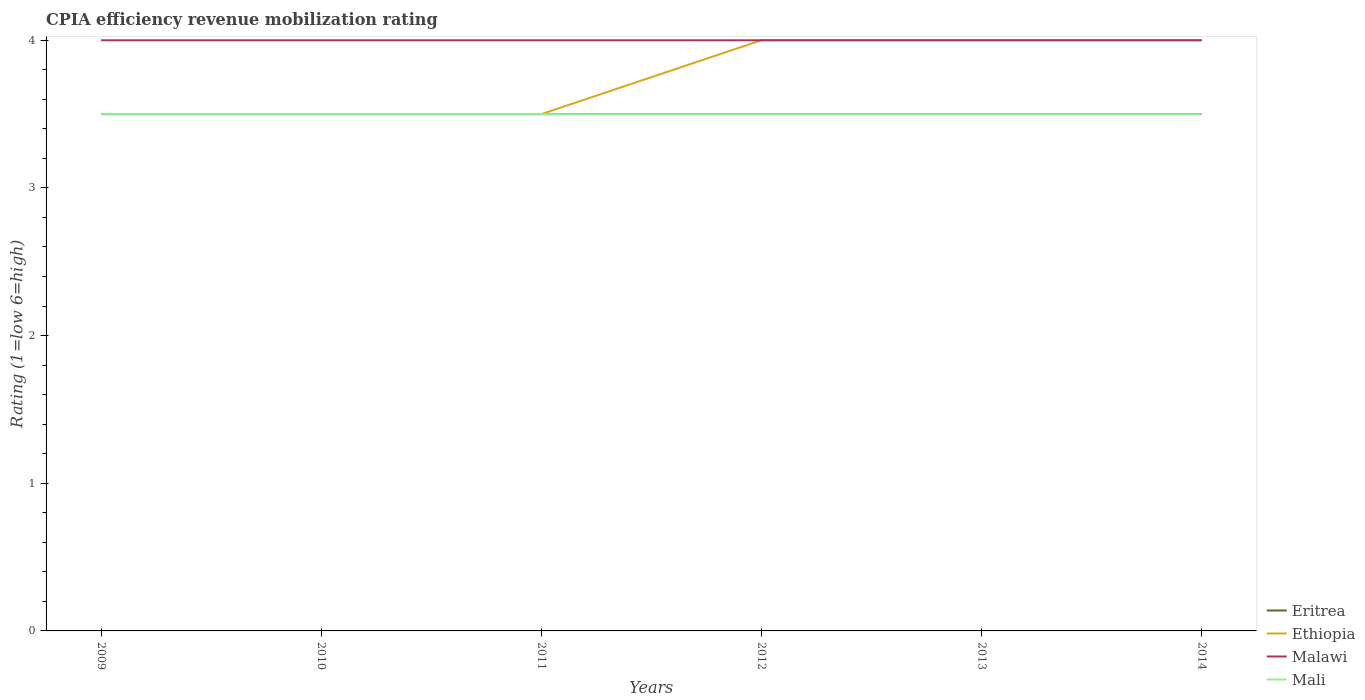How many different coloured lines are there?
Give a very brief answer. 4. Across all years, what is the maximum CPIA rating in Malawi?
Keep it short and to the point. 4. What is the total CPIA rating in Mali in the graph?
Provide a succinct answer. 0. What is the difference between two consecutive major ticks on the Y-axis?
Your response must be concise. 1. Does the graph contain grids?
Your answer should be very brief. No. Where does the legend appear in the graph?
Keep it short and to the point. Bottom right. How many legend labels are there?
Keep it short and to the point. 4. How are the legend labels stacked?
Your response must be concise. Vertical. What is the title of the graph?
Give a very brief answer. CPIA efficiency revenue mobilization rating. What is the label or title of the Y-axis?
Your answer should be compact. Rating (1=low 6=high). What is the Rating (1=low 6=high) of Ethiopia in 2009?
Your answer should be compact. 3.5. What is the Rating (1=low 6=high) in Malawi in 2009?
Ensure brevity in your answer.  4. What is the Rating (1=low 6=high) in Eritrea in 2010?
Your answer should be very brief. 3.5. What is the Rating (1=low 6=high) in Ethiopia in 2011?
Offer a terse response. 3.5. What is the Rating (1=low 6=high) in Mali in 2011?
Give a very brief answer. 3.5. What is the Rating (1=low 6=high) in Eritrea in 2012?
Make the answer very short. 3.5. What is the Rating (1=low 6=high) of Malawi in 2012?
Your response must be concise. 4. What is the Rating (1=low 6=high) of Mali in 2012?
Offer a terse response. 3.5. What is the Rating (1=low 6=high) of Eritrea in 2013?
Provide a short and direct response. 3.5. What is the Rating (1=low 6=high) in Mali in 2013?
Provide a short and direct response. 3.5. What is the Rating (1=low 6=high) of Ethiopia in 2014?
Give a very brief answer. 4. What is the Rating (1=low 6=high) in Mali in 2014?
Provide a short and direct response. 3.5. Across all years, what is the maximum Rating (1=low 6=high) in Eritrea?
Your response must be concise. 3.5. Across all years, what is the minimum Rating (1=low 6=high) in Eritrea?
Your answer should be compact. 3.5. Across all years, what is the minimum Rating (1=low 6=high) of Malawi?
Give a very brief answer. 4. What is the total Rating (1=low 6=high) of Eritrea in the graph?
Give a very brief answer. 21. What is the total Rating (1=low 6=high) of Ethiopia in the graph?
Keep it short and to the point. 22.5. What is the difference between the Rating (1=low 6=high) of Eritrea in 2009 and that in 2010?
Provide a succinct answer. 0. What is the difference between the Rating (1=low 6=high) of Mali in 2009 and that in 2010?
Provide a short and direct response. 0. What is the difference between the Rating (1=low 6=high) of Mali in 2009 and that in 2011?
Your answer should be compact. 0. What is the difference between the Rating (1=low 6=high) of Eritrea in 2009 and that in 2012?
Provide a short and direct response. 0. What is the difference between the Rating (1=low 6=high) in Ethiopia in 2009 and that in 2012?
Offer a terse response. -0.5. What is the difference between the Rating (1=low 6=high) in Malawi in 2009 and that in 2012?
Provide a succinct answer. 0. What is the difference between the Rating (1=low 6=high) in Eritrea in 2009 and that in 2013?
Provide a short and direct response. 0. What is the difference between the Rating (1=low 6=high) of Ethiopia in 2009 and that in 2013?
Keep it short and to the point. -0.5. What is the difference between the Rating (1=low 6=high) of Ethiopia in 2009 and that in 2014?
Provide a short and direct response. -0.5. What is the difference between the Rating (1=low 6=high) of Mali in 2009 and that in 2014?
Ensure brevity in your answer.  0. What is the difference between the Rating (1=low 6=high) of Eritrea in 2010 and that in 2011?
Provide a short and direct response. 0. What is the difference between the Rating (1=low 6=high) in Eritrea in 2010 and that in 2012?
Your answer should be very brief. 0. What is the difference between the Rating (1=low 6=high) in Ethiopia in 2010 and that in 2012?
Your answer should be compact. -0.5. What is the difference between the Rating (1=low 6=high) of Eritrea in 2010 and that in 2013?
Offer a terse response. 0. What is the difference between the Rating (1=low 6=high) in Ethiopia in 2010 and that in 2013?
Provide a short and direct response. -0.5. What is the difference between the Rating (1=low 6=high) in Mali in 2010 and that in 2013?
Provide a succinct answer. 0. What is the difference between the Rating (1=low 6=high) of Malawi in 2010 and that in 2014?
Ensure brevity in your answer.  0. What is the difference between the Rating (1=low 6=high) in Mali in 2010 and that in 2014?
Provide a succinct answer. 0. What is the difference between the Rating (1=low 6=high) of Ethiopia in 2011 and that in 2012?
Make the answer very short. -0.5. What is the difference between the Rating (1=low 6=high) of Malawi in 2011 and that in 2012?
Ensure brevity in your answer.  0. What is the difference between the Rating (1=low 6=high) in Malawi in 2011 and that in 2013?
Your answer should be very brief. 0. What is the difference between the Rating (1=low 6=high) in Ethiopia in 2011 and that in 2014?
Make the answer very short. -0.5. What is the difference between the Rating (1=low 6=high) of Eritrea in 2012 and that in 2013?
Keep it short and to the point. 0. What is the difference between the Rating (1=low 6=high) of Ethiopia in 2012 and that in 2013?
Your answer should be compact. 0. What is the difference between the Rating (1=low 6=high) of Malawi in 2012 and that in 2013?
Provide a succinct answer. 0. What is the difference between the Rating (1=low 6=high) in Mali in 2012 and that in 2013?
Offer a very short reply. 0. What is the difference between the Rating (1=low 6=high) in Eritrea in 2012 and that in 2014?
Offer a very short reply. 0. What is the difference between the Rating (1=low 6=high) of Ethiopia in 2012 and that in 2014?
Offer a very short reply. 0. What is the difference between the Rating (1=low 6=high) in Eritrea in 2009 and the Rating (1=low 6=high) in Ethiopia in 2010?
Your response must be concise. 0. What is the difference between the Rating (1=low 6=high) of Eritrea in 2009 and the Rating (1=low 6=high) of Malawi in 2010?
Provide a succinct answer. -0.5. What is the difference between the Rating (1=low 6=high) of Ethiopia in 2009 and the Rating (1=low 6=high) of Mali in 2010?
Offer a very short reply. 0. What is the difference between the Rating (1=low 6=high) of Eritrea in 2009 and the Rating (1=low 6=high) of Ethiopia in 2011?
Provide a short and direct response. 0. What is the difference between the Rating (1=low 6=high) of Malawi in 2009 and the Rating (1=low 6=high) of Mali in 2011?
Provide a short and direct response. 0.5. What is the difference between the Rating (1=low 6=high) in Eritrea in 2009 and the Rating (1=low 6=high) in Mali in 2012?
Your answer should be very brief. 0. What is the difference between the Rating (1=low 6=high) in Ethiopia in 2009 and the Rating (1=low 6=high) in Mali in 2012?
Offer a terse response. 0. What is the difference between the Rating (1=low 6=high) in Malawi in 2009 and the Rating (1=low 6=high) in Mali in 2012?
Your response must be concise. 0.5. What is the difference between the Rating (1=low 6=high) of Eritrea in 2009 and the Rating (1=low 6=high) of Ethiopia in 2013?
Give a very brief answer. -0.5. What is the difference between the Rating (1=low 6=high) of Eritrea in 2009 and the Rating (1=low 6=high) of Malawi in 2013?
Keep it short and to the point. -0.5. What is the difference between the Rating (1=low 6=high) of Ethiopia in 2009 and the Rating (1=low 6=high) of Malawi in 2013?
Make the answer very short. -0.5. What is the difference between the Rating (1=low 6=high) of Malawi in 2009 and the Rating (1=low 6=high) of Mali in 2013?
Offer a very short reply. 0.5. What is the difference between the Rating (1=low 6=high) of Eritrea in 2009 and the Rating (1=low 6=high) of Ethiopia in 2014?
Give a very brief answer. -0.5. What is the difference between the Rating (1=low 6=high) of Eritrea in 2009 and the Rating (1=low 6=high) of Mali in 2014?
Your answer should be compact. 0. What is the difference between the Rating (1=low 6=high) of Eritrea in 2010 and the Rating (1=low 6=high) of Mali in 2011?
Ensure brevity in your answer.  0. What is the difference between the Rating (1=low 6=high) of Ethiopia in 2010 and the Rating (1=low 6=high) of Malawi in 2011?
Make the answer very short. -0.5. What is the difference between the Rating (1=low 6=high) in Ethiopia in 2010 and the Rating (1=low 6=high) in Mali in 2011?
Your response must be concise. 0. What is the difference between the Rating (1=low 6=high) in Eritrea in 2010 and the Rating (1=low 6=high) in Ethiopia in 2012?
Give a very brief answer. -0.5. What is the difference between the Rating (1=low 6=high) in Ethiopia in 2010 and the Rating (1=low 6=high) in Mali in 2012?
Your answer should be very brief. 0. What is the difference between the Rating (1=low 6=high) in Malawi in 2010 and the Rating (1=low 6=high) in Mali in 2012?
Provide a short and direct response. 0.5. What is the difference between the Rating (1=low 6=high) of Eritrea in 2010 and the Rating (1=low 6=high) of Ethiopia in 2013?
Your answer should be compact. -0.5. What is the difference between the Rating (1=low 6=high) of Eritrea in 2010 and the Rating (1=low 6=high) of Mali in 2013?
Make the answer very short. 0. What is the difference between the Rating (1=low 6=high) of Ethiopia in 2010 and the Rating (1=low 6=high) of Mali in 2013?
Keep it short and to the point. 0. What is the difference between the Rating (1=low 6=high) of Malawi in 2010 and the Rating (1=low 6=high) of Mali in 2013?
Offer a terse response. 0.5. What is the difference between the Rating (1=low 6=high) of Eritrea in 2010 and the Rating (1=low 6=high) of Malawi in 2014?
Keep it short and to the point. -0.5. What is the difference between the Rating (1=low 6=high) in Eritrea in 2010 and the Rating (1=low 6=high) in Mali in 2014?
Your answer should be very brief. 0. What is the difference between the Rating (1=low 6=high) of Eritrea in 2011 and the Rating (1=low 6=high) of Ethiopia in 2012?
Keep it short and to the point. -0.5. What is the difference between the Rating (1=low 6=high) of Eritrea in 2011 and the Rating (1=low 6=high) of Malawi in 2012?
Keep it short and to the point. -0.5. What is the difference between the Rating (1=low 6=high) in Malawi in 2011 and the Rating (1=low 6=high) in Mali in 2012?
Offer a terse response. 0.5. What is the difference between the Rating (1=low 6=high) in Eritrea in 2011 and the Rating (1=low 6=high) in Malawi in 2013?
Offer a very short reply. -0.5. What is the difference between the Rating (1=low 6=high) in Ethiopia in 2011 and the Rating (1=low 6=high) in Malawi in 2013?
Provide a short and direct response. -0.5. What is the difference between the Rating (1=low 6=high) in Ethiopia in 2011 and the Rating (1=low 6=high) in Mali in 2013?
Offer a terse response. 0. What is the difference between the Rating (1=low 6=high) in Eritrea in 2011 and the Rating (1=low 6=high) in Mali in 2014?
Your answer should be compact. 0. What is the difference between the Rating (1=low 6=high) in Ethiopia in 2011 and the Rating (1=low 6=high) in Mali in 2014?
Offer a very short reply. 0. What is the difference between the Rating (1=low 6=high) in Eritrea in 2012 and the Rating (1=low 6=high) in Ethiopia in 2013?
Offer a terse response. -0.5. What is the difference between the Rating (1=low 6=high) of Eritrea in 2012 and the Rating (1=low 6=high) of Malawi in 2013?
Your answer should be compact. -0.5. What is the difference between the Rating (1=low 6=high) of Malawi in 2012 and the Rating (1=low 6=high) of Mali in 2013?
Give a very brief answer. 0.5. What is the difference between the Rating (1=low 6=high) in Eritrea in 2012 and the Rating (1=low 6=high) in Ethiopia in 2014?
Your answer should be very brief. -0.5. What is the difference between the Rating (1=low 6=high) of Eritrea in 2012 and the Rating (1=low 6=high) of Malawi in 2014?
Your response must be concise. -0.5. What is the difference between the Rating (1=low 6=high) of Eritrea in 2013 and the Rating (1=low 6=high) of Malawi in 2014?
Give a very brief answer. -0.5. What is the difference between the Rating (1=low 6=high) in Ethiopia in 2013 and the Rating (1=low 6=high) in Malawi in 2014?
Give a very brief answer. 0. What is the difference between the Rating (1=low 6=high) of Malawi in 2013 and the Rating (1=low 6=high) of Mali in 2014?
Your answer should be compact. 0.5. What is the average Rating (1=low 6=high) of Eritrea per year?
Provide a succinct answer. 3.5. What is the average Rating (1=low 6=high) of Ethiopia per year?
Provide a succinct answer. 3.75. What is the average Rating (1=low 6=high) in Malawi per year?
Your answer should be compact. 4. In the year 2009, what is the difference between the Rating (1=low 6=high) of Eritrea and Rating (1=low 6=high) of Ethiopia?
Your response must be concise. 0. In the year 2009, what is the difference between the Rating (1=low 6=high) of Ethiopia and Rating (1=low 6=high) of Malawi?
Keep it short and to the point. -0.5. In the year 2009, what is the difference between the Rating (1=low 6=high) in Ethiopia and Rating (1=low 6=high) in Mali?
Keep it short and to the point. 0. In the year 2009, what is the difference between the Rating (1=low 6=high) of Malawi and Rating (1=low 6=high) of Mali?
Make the answer very short. 0.5. In the year 2010, what is the difference between the Rating (1=low 6=high) in Eritrea and Rating (1=low 6=high) in Ethiopia?
Offer a terse response. 0. In the year 2010, what is the difference between the Rating (1=low 6=high) in Ethiopia and Rating (1=low 6=high) in Malawi?
Offer a terse response. -0.5. In the year 2010, what is the difference between the Rating (1=low 6=high) in Malawi and Rating (1=low 6=high) in Mali?
Give a very brief answer. 0.5. In the year 2011, what is the difference between the Rating (1=low 6=high) of Eritrea and Rating (1=low 6=high) of Ethiopia?
Give a very brief answer. 0. In the year 2011, what is the difference between the Rating (1=low 6=high) in Eritrea and Rating (1=low 6=high) in Malawi?
Your answer should be compact. -0.5. In the year 2011, what is the difference between the Rating (1=low 6=high) in Eritrea and Rating (1=low 6=high) in Mali?
Give a very brief answer. 0. In the year 2011, what is the difference between the Rating (1=low 6=high) of Ethiopia and Rating (1=low 6=high) of Malawi?
Your response must be concise. -0.5. In the year 2011, what is the difference between the Rating (1=low 6=high) in Ethiopia and Rating (1=low 6=high) in Mali?
Ensure brevity in your answer.  0. In the year 2011, what is the difference between the Rating (1=low 6=high) of Malawi and Rating (1=low 6=high) of Mali?
Offer a very short reply. 0.5. In the year 2012, what is the difference between the Rating (1=low 6=high) in Eritrea and Rating (1=low 6=high) in Ethiopia?
Ensure brevity in your answer.  -0.5. In the year 2012, what is the difference between the Rating (1=low 6=high) in Eritrea and Rating (1=low 6=high) in Mali?
Your answer should be compact. 0. In the year 2012, what is the difference between the Rating (1=low 6=high) of Ethiopia and Rating (1=low 6=high) of Malawi?
Keep it short and to the point. 0. In the year 2012, what is the difference between the Rating (1=low 6=high) of Malawi and Rating (1=low 6=high) of Mali?
Ensure brevity in your answer.  0.5. In the year 2013, what is the difference between the Rating (1=low 6=high) of Eritrea and Rating (1=low 6=high) of Ethiopia?
Your response must be concise. -0.5. In the year 2013, what is the difference between the Rating (1=low 6=high) in Eritrea and Rating (1=low 6=high) in Malawi?
Offer a terse response. -0.5. In the year 2014, what is the difference between the Rating (1=low 6=high) in Eritrea and Rating (1=low 6=high) in Ethiopia?
Keep it short and to the point. -0.5. In the year 2014, what is the difference between the Rating (1=low 6=high) in Eritrea and Rating (1=low 6=high) in Malawi?
Your response must be concise. -0.5. In the year 2014, what is the difference between the Rating (1=low 6=high) in Eritrea and Rating (1=low 6=high) in Mali?
Offer a terse response. 0. In the year 2014, what is the difference between the Rating (1=low 6=high) of Ethiopia and Rating (1=low 6=high) of Malawi?
Offer a terse response. 0. In the year 2014, what is the difference between the Rating (1=low 6=high) of Ethiopia and Rating (1=low 6=high) of Mali?
Ensure brevity in your answer.  0.5. In the year 2014, what is the difference between the Rating (1=low 6=high) in Malawi and Rating (1=low 6=high) in Mali?
Your answer should be compact. 0.5. What is the ratio of the Rating (1=low 6=high) of Malawi in 2009 to that in 2010?
Your response must be concise. 1. What is the ratio of the Rating (1=low 6=high) of Eritrea in 2009 to that in 2011?
Provide a succinct answer. 1. What is the ratio of the Rating (1=low 6=high) in Ethiopia in 2009 to that in 2012?
Your answer should be compact. 0.88. What is the ratio of the Rating (1=low 6=high) in Malawi in 2009 to that in 2012?
Give a very brief answer. 1. What is the ratio of the Rating (1=low 6=high) in Eritrea in 2009 to that in 2013?
Provide a succinct answer. 1. What is the ratio of the Rating (1=low 6=high) in Ethiopia in 2009 to that in 2013?
Provide a short and direct response. 0.88. What is the ratio of the Rating (1=low 6=high) in Mali in 2009 to that in 2013?
Your response must be concise. 1. What is the ratio of the Rating (1=low 6=high) in Eritrea in 2009 to that in 2014?
Offer a terse response. 1. What is the ratio of the Rating (1=low 6=high) of Malawi in 2009 to that in 2014?
Make the answer very short. 1. What is the ratio of the Rating (1=low 6=high) in Malawi in 2010 to that in 2012?
Make the answer very short. 1. What is the ratio of the Rating (1=low 6=high) in Mali in 2010 to that in 2012?
Provide a short and direct response. 1. What is the ratio of the Rating (1=low 6=high) of Ethiopia in 2010 to that in 2013?
Keep it short and to the point. 0.88. What is the ratio of the Rating (1=low 6=high) of Malawi in 2010 to that in 2013?
Your response must be concise. 1. What is the ratio of the Rating (1=low 6=high) in Mali in 2010 to that in 2013?
Your answer should be very brief. 1. What is the ratio of the Rating (1=low 6=high) of Eritrea in 2010 to that in 2014?
Provide a short and direct response. 1. What is the ratio of the Rating (1=low 6=high) of Malawi in 2010 to that in 2014?
Provide a short and direct response. 1. What is the ratio of the Rating (1=low 6=high) in Mali in 2010 to that in 2014?
Provide a short and direct response. 1. What is the ratio of the Rating (1=low 6=high) of Eritrea in 2011 to that in 2012?
Keep it short and to the point. 1. What is the ratio of the Rating (1=low 6=high) in Malawi in 2011 to that in 2012?
Your answer should be very brief. 1. What is the ratio of the Rating (1=low 6=high) in Mali in 2011 to that in 2012?
Offer a very short reply. 1. What is the ratio of the Rating (1=low 6=high) in Ethiopia in 2011 to that in 2013?
Make the answer very short. 0.88. What is the ratio of the Rating (1=low 6=high) of Ethiopia in 2011 to that in 2014?
Ensure brevity in your answer.  0.88. What is the ratio of the Rating (1=low 6=high) of Mali in 2011 to that in 2014?
Your answer should be very brief. 1. What is the ratio of the Rating (1=low 6=high) of Eritrea in 2012 to that in 2013?
Your answer should be very brief. 1. What is the ratio of the Rating (1=low 6=high) of Ethiopia in 2012 to that in 2013?
Ensure brevity in your answer.  1. What is the ratio of the Rating (1=low 6=high) of Malawi in 2012 to that in 2013?
Give a very brief answer. 1. What is the ratio of the Rating (1=low 6=high) in Mali in 2012 to that in 2013?
Your answer should be compact. 1. What is the ratio of the Rating (1=low 6=high) of Eritrea in 2012 to that in 2014?
Keep it short and to the point. 1. What is the ratio of the Rating (1=low 6=high) of Ethiopia in 2012 to that in 2014?
Ensure brevity in your answer.  1. What is the ratio of the Rating (1=low 6=high) of Malawi in 2012 to that in 2014?
Your answer should be very brief. 1. What is the ratio of the Rating (1=low 6=high) in Mali in 2012 to that in 2014?
Keep it short and to the point. 1. What is the ratio of the Rating (1=low 6=high) in Eritrea in 2013 to that in 2014?
Ensure brevity in your answer.  1. What is the ratio of the Rating (1=low 6=high) in Ethiopia in 2013 to that in 2014?
Offer a very short reply. 1. What is the ratio of the Rating (1=low 6=high) of Malawi in 2013 to that in 2014?
Ensure brevity in your answer.  1. What is the ratio of the Rating (1=low 6=high) of Mali in 2013 to that in 2014?
Make the answer very short. 1. What is the difference between the highest and the second highest Rating (1=low 6=high) of Ethiopia?
Your answer should be very brief. 0. What is the difference between the highest and the second highest Rating (1=low 6=high) in Malawi?
Your response must be concise. 0. What is the difference between the highest and the lowest Rating (1=low 6=high) of Eritrea?
Provide a succinct answer. 0. What is the difference between the highest and the lowest Rating (1=low 6=high) in Ethiopia?
Offer a terse response. 0.5. 